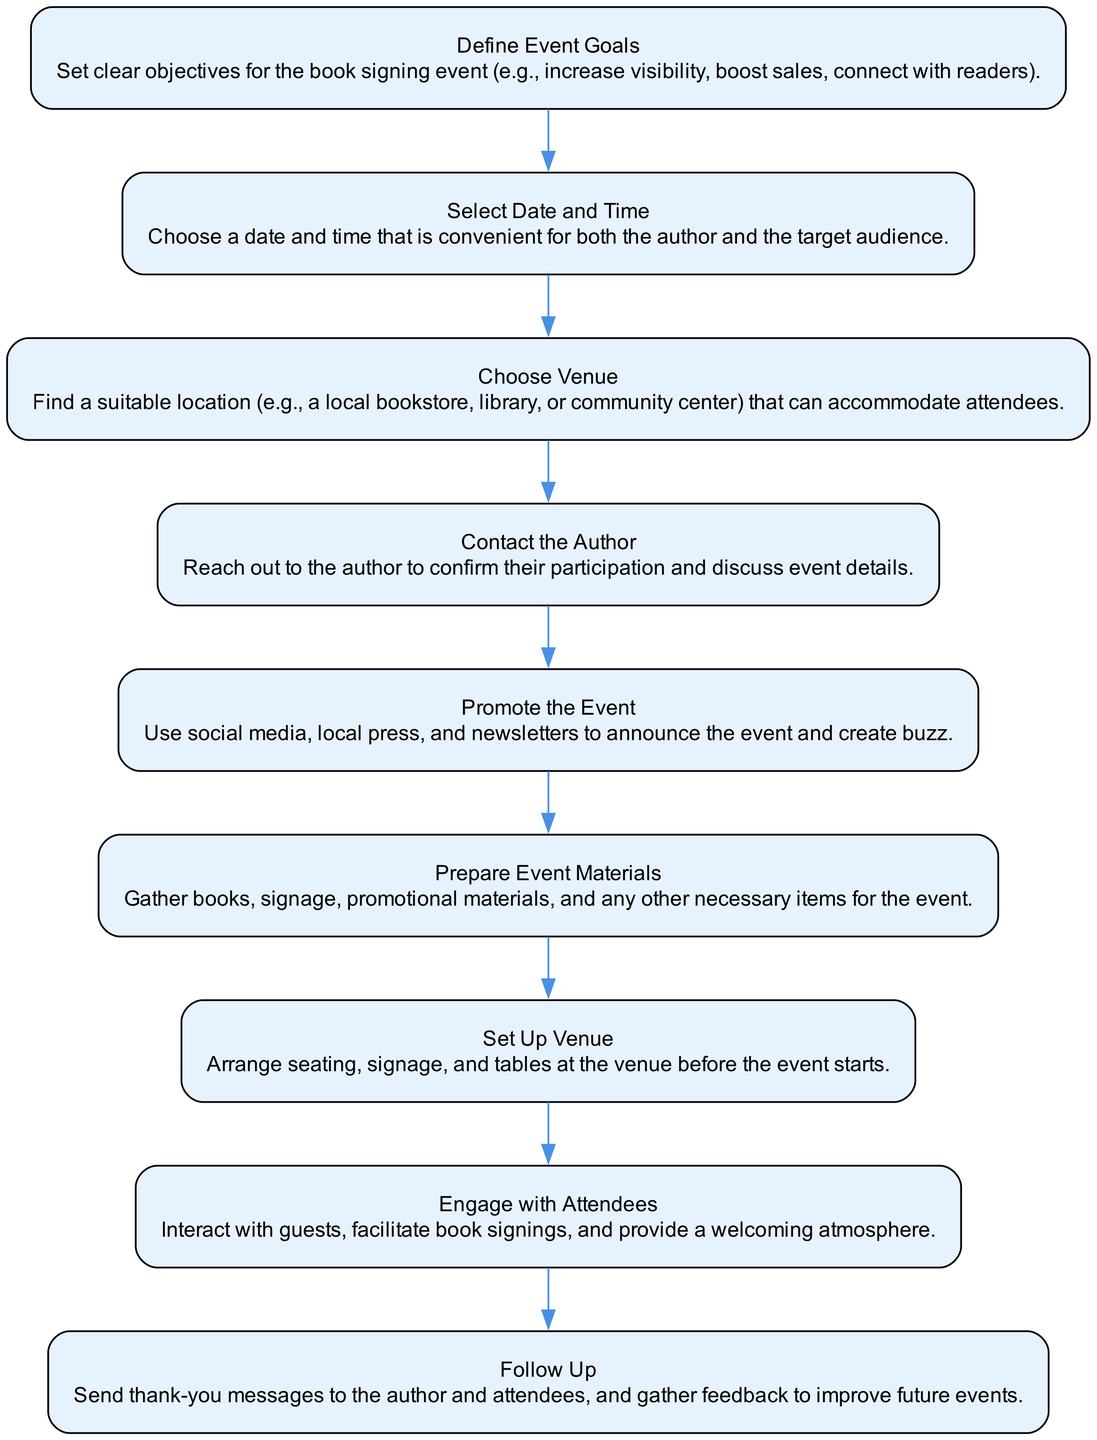What is the first step in the process? The first step listed in the flow chart is "Define Event Goals", which sets the objectives for the book signing event.
Answer: Define Event Goals How many nodes are in the diagram? The flow chart contains a total of 9 nodes, representing each step in hosting a successful book signing event.
Answer: 9 Which step involves discussing event details with the author? The step that involves discussing event details with the author is "Contact the Author."
Answer: Contact the Author What is the last step in the flow chart? The last step listed is "Follow Up," which includes sending thank-you messages and gathering feedback.
Answer: Follow Up Which steps are directly related to promoting the event? The steps directly related to promoting the event are "Promote the Event" and "Engage with Attendees."
Answer: Promote the Event, Engage with Attendees What is the relationship between "Choose Venue" and "Set Up Venue"? "Choose Venue" occurs before "Set Up Venue," as the venue must first be selected before any setup can take place.
Answer: Choose Venue → Set Up Venue How many types of activities are captured in the diagram? There are three types of activities captured: planning, promoting, and executing the event.
Answer: 3 Which step requires gathering materials? The step that requires gathering materials is "Prepare Event Materials."
Answer: Prepare Event Materials What common theme do the first three steps share? The common theme shared by the first three steps is preparation for the event, focusing on defining goals, scheduling, and venue selection.
Answer: Preparation 